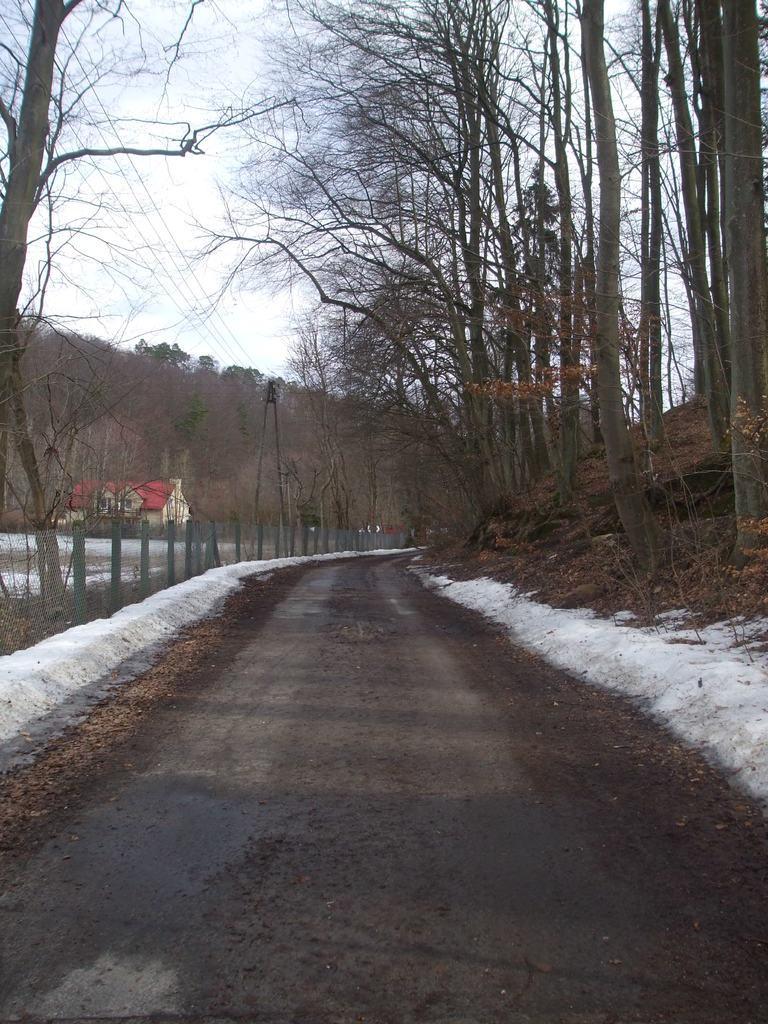Could you give a brief overview of what you see in this image? As we can see in the image there are trees, fence, house and current pole. On the top there is sky. 